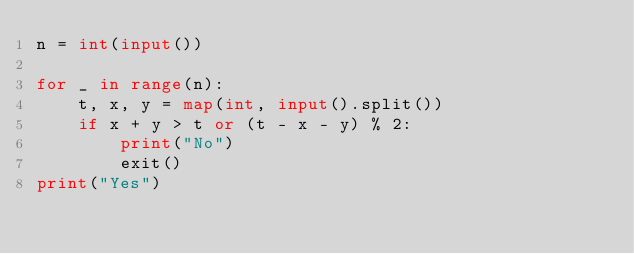<code> <loc_0><loc_0><loc_500><loc_500><_Python_>n = int(input())

for _ in range(n):
    t, x, y = map(int, input().split())
    if x + y > t or (t - x - y) % 2:
        print("No")
        exit()
print("Yes")</code> 